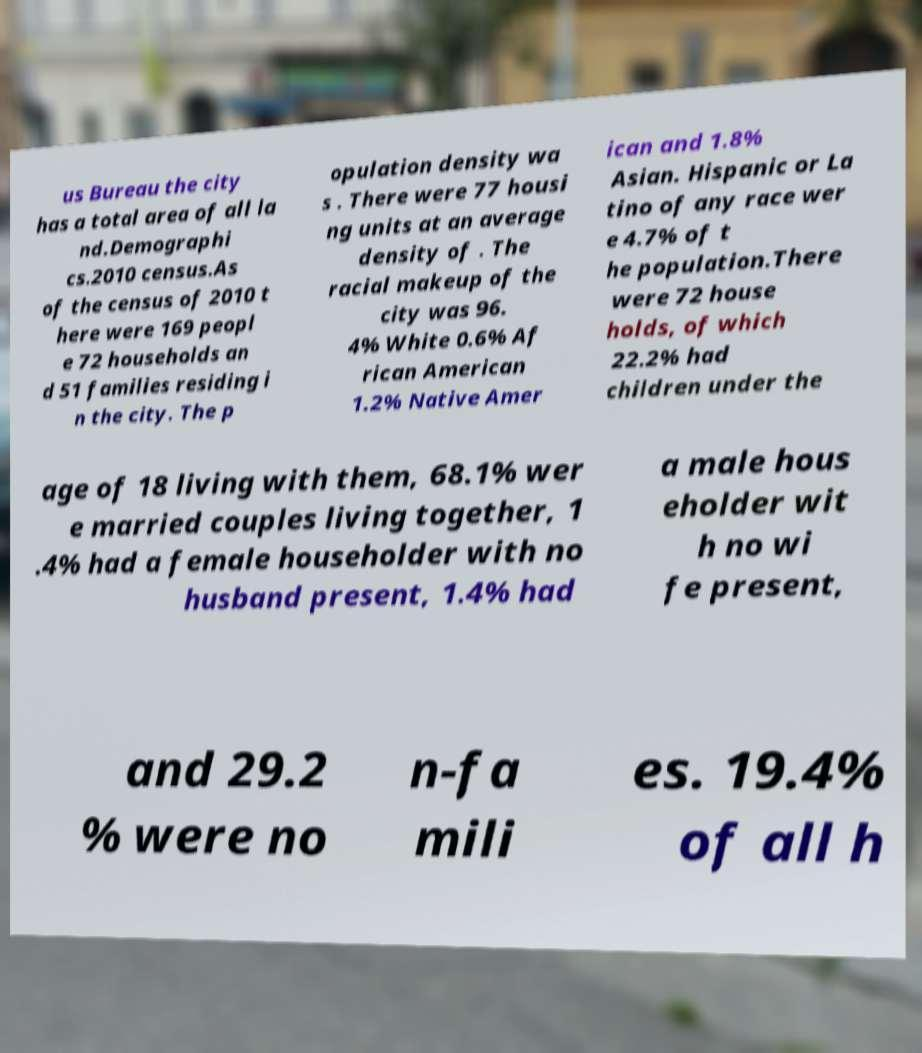Please identify and transcribe the text found in this image. us Bureau the city has a total area of all la nd.Demographi cs.2010 census.As of the census of 2010 t here were 169 peopl e 72 households an d 51 families residing i n the city. The p opulation density wa s . There were 77 housi ng units at an average density of . The racial makeup of the city was 96. 4% White 0.6% Af rican American 1.2% Native Amer ican and 1.8% Asian. Hispanic or La tino of any race wer e 4.7% of t he population.There were 72 house holds, of which 22.2% had children under the age of 18 living with them, 68.1% wer e married couples living together, 1 .4% had a female householder with no husband present, 1.4% had a male hous eholder wit h no wi fe present, and 29.2 % were no n-fa mili es. 19.4% of all h 